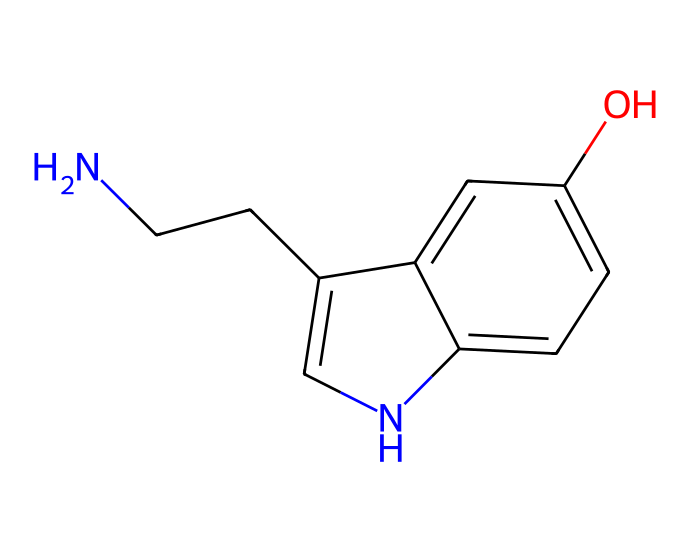What is the name of this chemical? The SMILES representation corresponds to serotonin, which is a well-known neurotransmitter. This is identified by recognizing the structure that includes the indole ring and amine group characteristic of serotonin.
Answer: serotonin How many carbon atoms are present in this structure? By analyzing the SMILES, we count the carbon atoms indicated in the structure. There are a total of 9 carbon atoms in the representation provided.
Answer: 9 What functional groups are present in this chemical? The chemical structure shows an amine group (–NH2) and a hydroxyl group (–OH), which are significant functional groups present in serotonin. These are observed from the structure that includes nitrogen and oxygen connections.
Answer: amine and hydroxyl How many rings are in the structure of serotonin? Looking at the structure, we see one fused bicyclic system, meaning there are two interconnected rings. Count these connections confirms that there are two rings.
Answer: 2 What type of neurotransmitter is serotonin classified as? Serotonin is classified as a monoamine neurotransmitter, which can be identified based on its structure that contains a single amine group and is derived from amino acids.
Answer: monoamine What property is associated with the hydroxyl group in serotonin? The presence of the hydroxyl group in serotonin contributes to its hydrophilicity, which affects its solubility in water and biological systems, influencing its role as a neurotransmitter in the brain.
Answer: hydrophilicity 